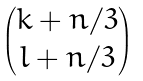<formula> <loc_0><loc_0><loc_500><loc_500>\begin{pmatrix} k + n / 3 \\ l + n / 3 \end{pmatrix}</formula> 